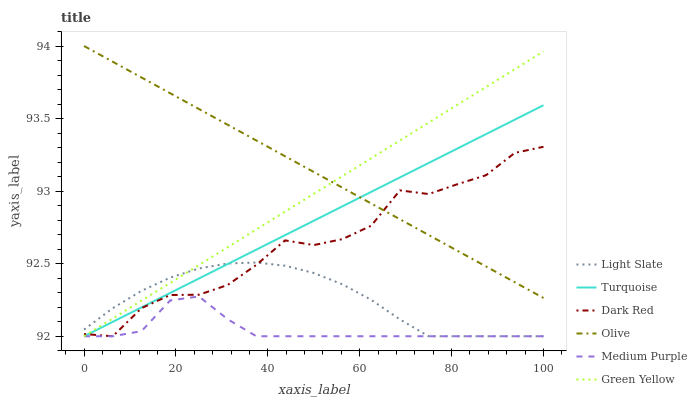Does Medium Purple have the minimum area under the curve?
Answer yes or no. Yes. Does Olive have the maximum area under the curve?
Answer yes or no. Yes. Does Light Slate have the minimum area under the curve?
Answer yes or no. No. Does Light Slate have the maximum area under the curve?
Answer yes or no. No. Is Green Yellow the smoothest?
Answer yes or no. Yes. Is Dark Red the roughest?
Answer yes or no. Yes. Is Light Slate the smoothest?
Answer yes or no. No. Is Light Slate the roughest?
Answer yes or no. No. Does Turquoise have the lowest value?
Answer yes or no. Yes. Does Olive have the lowest value?
Answer yes or no. No. Does Olive have the highest value?
Answer yes or no. Yes. Does Light Slate have the highest value?
Answer yes or no. No. Is Medium Purple less than Olive?
Answer yes or no. Yes. Is Olive greater than Light Slate?
Answer yes or no. Yes. Does Turquoise intersect Medium Purple?
Answer yes or no. Yes. Is Turquoise less than Medium Purple?
Answer yes or no. No. Is Turquoise greater than Medium Purple?
Answer yes or no. No. Does Medium Purple intersect Olive?
Answer yes or no. No. 